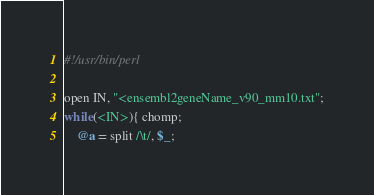<code> <loc_0><loc_0><loc_500><loc_500><_Perl_>#!/usr/bin/perl

open IN, "<ensembl2geneName_v90_mm10.txt";
while(<IN>){ chomp;
	@a = split /\t/, $_;</code> 